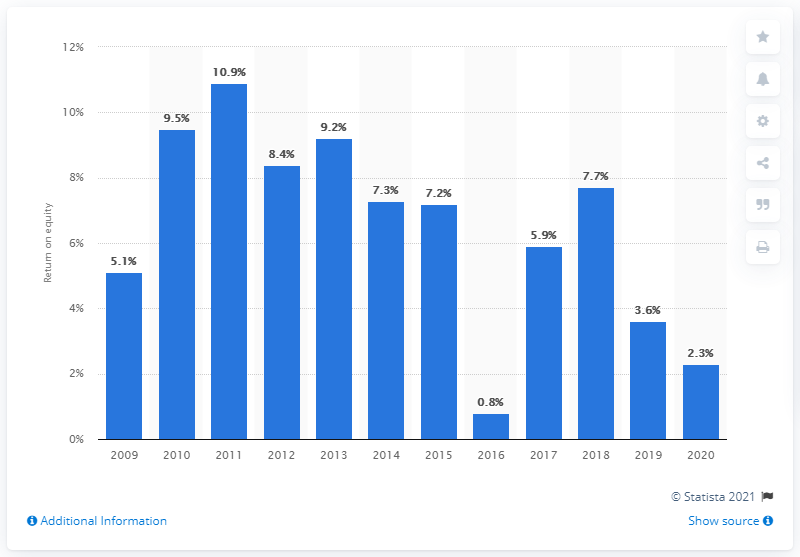Identify some key points in this picture. In 2020, the average ordinary shareholders' equity at HSBC generated a return of approximately 2.3%. In 2019, the value of ordinary shareholders' equity at HSBC was 3.6 trillion dollars. 